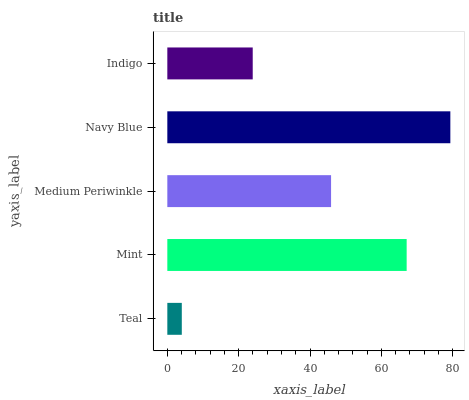Is Teal the minimum?
Answer yes or no. Yes. Is Navy Blue the maximum?
Answer yes or no. Yes. Is Mint the minimum?
Answer yes or no. No. Is Mint the maximum?
Answer yes or no. No. Is Mint greater than Teal?
Answer yes or no. Yes. Is Teal less than Mint?
Answer yes or no. Yes. Is Teal greater than Mint?
Answer yes or no. No. Is Mint less than Teal?
Answer yes or no. No. Is Medium Periwinkle the high median?
Answer yes or no. Yes. Is Medium Periwinkle the low median?
Answer yes or no. Yes. Is Navy Blue the high median?
Answer yes or no. No. Is Navy Blue the low median?
Answer yes or no. No. 